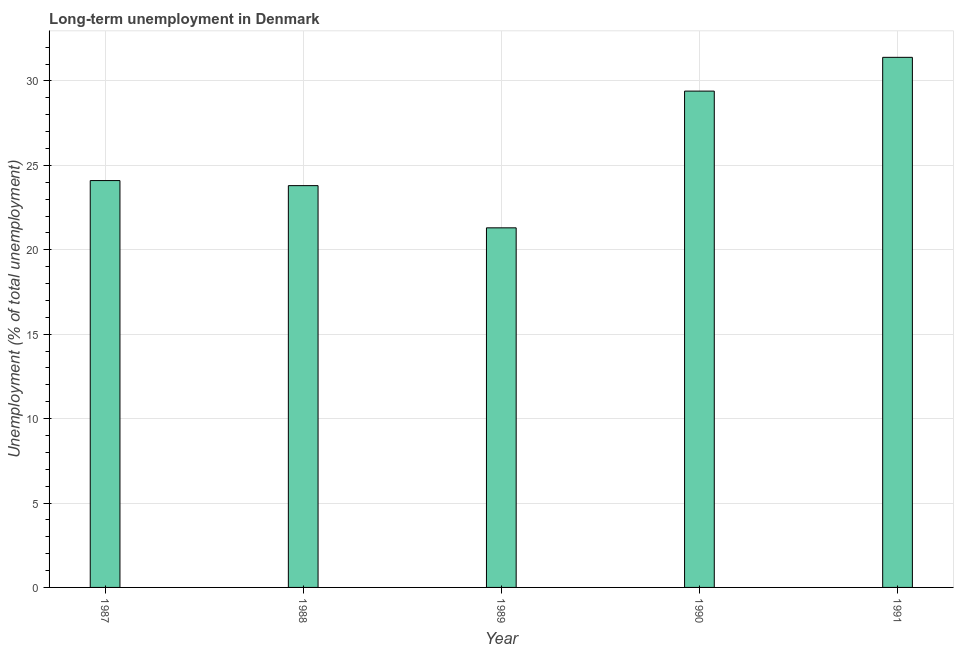Does the graph contain any zero values?
Offer a very short reply. No. What is the title of the graph?
Provide a succinct answer. Long-term unemployment in Denmark. What is the label or title of the X-axis?
Offer a terse response. Year. What is the label or title of the Y-axis?
Your answer should be compact. Unemployment (% of total unemployment). What is the long-term unemployment in 1988?
Your answer should be very brief. 23.8. Across all years, what is the maximum long-term unemployment?
Offer a terse response. 31.4. Across all years, what is the minimum long-term unemployment?
Offer a very short reply. 21.3. In which year was the long-term unemployment minimum?
Offer a very short reply. 1989. What is the sum of the long-term unemployment?
Keep it short and to the point. 130. What is the difference between the long-term unemployment in 1987 and 1989?
Keep it short and to the point. 2.8. What is the median long-term unemployment?
Offer a terse response. 24.1. What is the ratio of the long-term unemployment in 1989 to that in 1991?
Your answer should be compact. 0.68. Is the long-term unemployment in 1989 less than that in 1991?
Make the answer very short. Yes. Is the difference between the long-term unemployment in 1987 and 1989 greater than the difference between any two years?
Make the answer very short. No. Is the sum of the long-term unemployment in 1989 and 1990 greater than the maximum long-term unemployment across all years?
Give a very brief answer. Yes. In how many years, is the long-term unemployment greater than the average long-term unemployment taken over all years?
Make the answer very short. 2. Are all the bars in the graph horizontal?
Your answer should be compact. No. How many years are there in the graph?
Offer a very short reply. 5. What is the difference between two consecutive major ticks on the Y-axis?
Your answer should be compact. 5. What is the Unemployment (% of total unemployment) in 1987?
Ensure brevity in your answer.  24.1. What is the Unemployment (% of total unemployment) of 1988?
Keep it short and to the point. 23.8. What is the Unemployment (% of total unemployment) of 1989?
Provide a succinct answer. 21.3. What is the Unemployment (% of total unemployment) in 1990?
Ensure brevity in your answer.  29.4. What is the Unemployment (% of total unemployment) of 1991?
Make the answer very short. 31.4. What is the difference between the Unemployment (% of total unemployment) in 1987 and 1990?
Make the answer very short. -5.3. What is the difference between the Unemployment (% of total unemployment) in 1988 and 1989?
Provide a short and direct response. 2.5. What is the difference between the Unemployment (% of total unemployment) in 1989 and 1991?
Your response must be concise. -10.1. What is the difference between the Unemployment (% of total unemployment) in 1990 and 1991?
Make the answer very short. -2. What is the ratio of the Unemployment (% of total unemployment) in 1987 to that in 1988?
Make the answer very short. 1.01. What is the ratio of the Unemployment (% of total unemployment) in 1987 to that in 1989?
Offer a terse response. 1.13. What is the ratio of the Unemployment (% of total unemployment) in 1987 to that in 1990?
Provide a short and direct response. 0.82. What is the ratio of the Unemployment (% of total unemployment) in 1987 to that in 1991?
Offer a very short reply. 0.77. What is the ratio of the Unemployment (% of total unemployment) in 1988 to that in 1989?
Give a very brief answer. 1.12. What is the ratio of the Unemployment (% of total unemployment) in 1988 to that in 1990?
Provide a short and direct response. 0.81. What is the ratio of the Unemployment (% of total unemployment) in 1988 to that in 1991?
Keep it short and to the point. 0.76. What is the ratio of the Unemployment (% of total unemployment) in 1989 to that in 1990?
Give a very brief answer. 0.72. What is the ratio of the Unemployment (% of total unemployment) in 1989 to that in 1991?
Your response must be concise. 0.68. What is the ratio of the Unemployment (% of total unemployment) in 1990 to that in 1991?
Offer a very short reply. 0.94. 